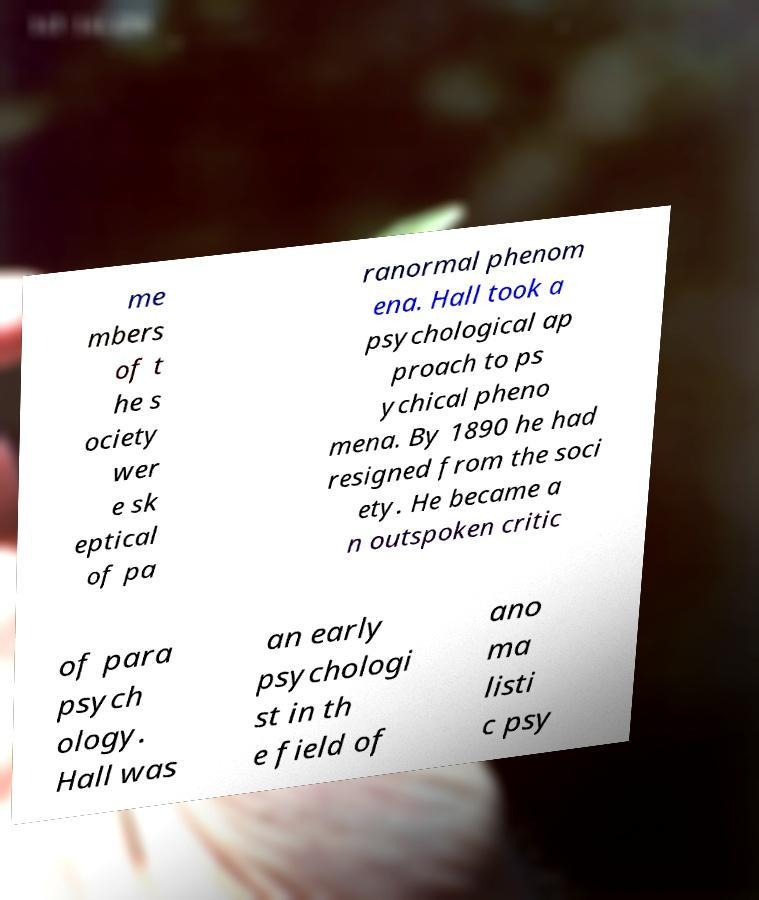Please identify and transcribe the text found in this image. me mbers of t he s ociety wer e sk eptical of pa ranormal phenom ena. Hall took a psychological ap proach to ps ychical pheno mena. By 1890 he had resigned from the soci ety. He became a n outspoken critic of para psych ology. Hall was an early psychologi st in th e field of ano ma listi c psy 